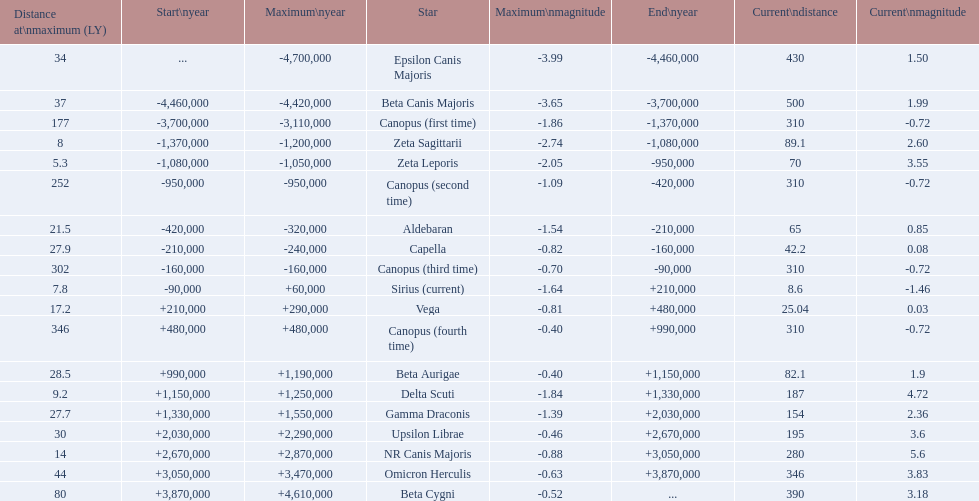What are the historical brightest stars? Epsilon Canis Majoris, Beta Canis Majoris, Canopus (first time), Zeta Sagittarii, Zeta Leporis, Canopus (second time), Aldebaran, Capella, Canopus (third time), Sirius (current), Vega, Canopus (fourth time), Beta Aurigae, Delta Scuti, Gamma Draconis, Upsilon Librae, NR Canis Majoris, Omicron Herculis, Beta Cygni. Of those which star has a distance at maximum of 80 Beta Cygni. 